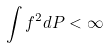<formula> <loc_0><loc_0><loc_500><loc_500>\int f ^ { 2 } d P < \infty</formula> 